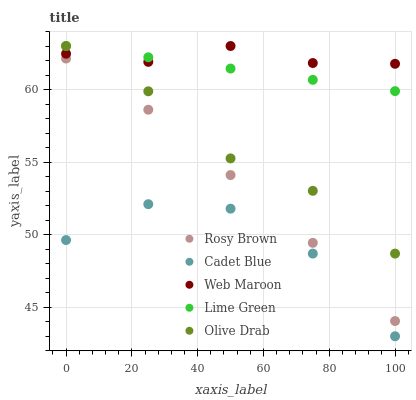Does Cadet Blue have the minimum area under the curve?
Answer yes or no. Yes. Does Web Maroon have the maximum area under the curve?
Answer yes or no. Yes. Does Lime Green have the minimum area under the curve?
Answer yes or no. No. Does Lime Green have the maximum area under the curve?
Answer yes or no. No. Is Lime Green the smoothest?
Answer yes or no. Yes. Is Cadet Blue the roughest?
Answer yes or no. Yes. Is Rosy Brown the smoothest?
Answer yes or no. No. Is Rosy Brown the roughest?
Answer yes or no. No. Does Cadet Blue have the lowest value?
Answer yes or no. Yes. Does Lime Green have the lowest value?
Answer yes or no. No. Does Olive Drab have the highest value?
Answer yes or no. Yes. Does Rosy Brown have the highest value?
Answer yes or no. No. Is Rosy Brown less than Lime Green?
Answer yes or no. Yes. Is Lime Green greater than Cadet Blue?
Answer yes or no. Yes. Does Olive Drab intersect Web Maroon?
Answer yes or no. Yes. Is Olive Drab less than Web Maroon?
Answer yes or no. No. Is Olive Drab greater than Web Maroon?
Answer yes or no. No. Does Rosy Brown intersect Lime Green?
Answer yes or no. No. 